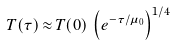<formula> <loc_0><loc_0><loc_500><loc_500>T ( { \tau } ) \, { \approx } \, T ( 0 ) \, \left ( e ^ { - { \tau } / { \mu } _ { 0 } } \right ) ^ { 1 / 4 }</formula> 